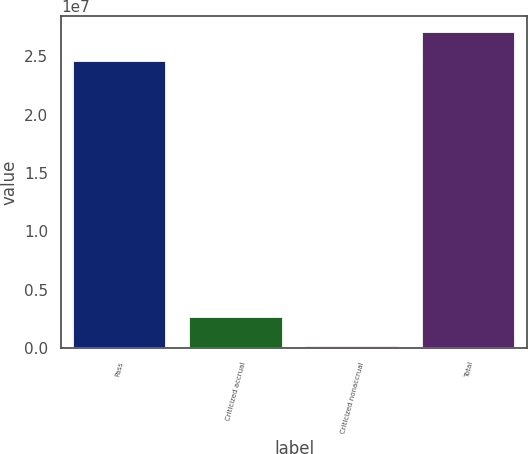Convert chart to OTSL. <chart><loc_0><loc_0><loc_500><loc_500><bar_chart><fcel>Pass<fcel>Criticized accrual<fcel>Criticized nonaccrual<fcel>Total<nl><fcel>2.45703e+07<fcel>2.70736e+06<fcel>176201<fcel>2.71014e+07<nl></chart> 